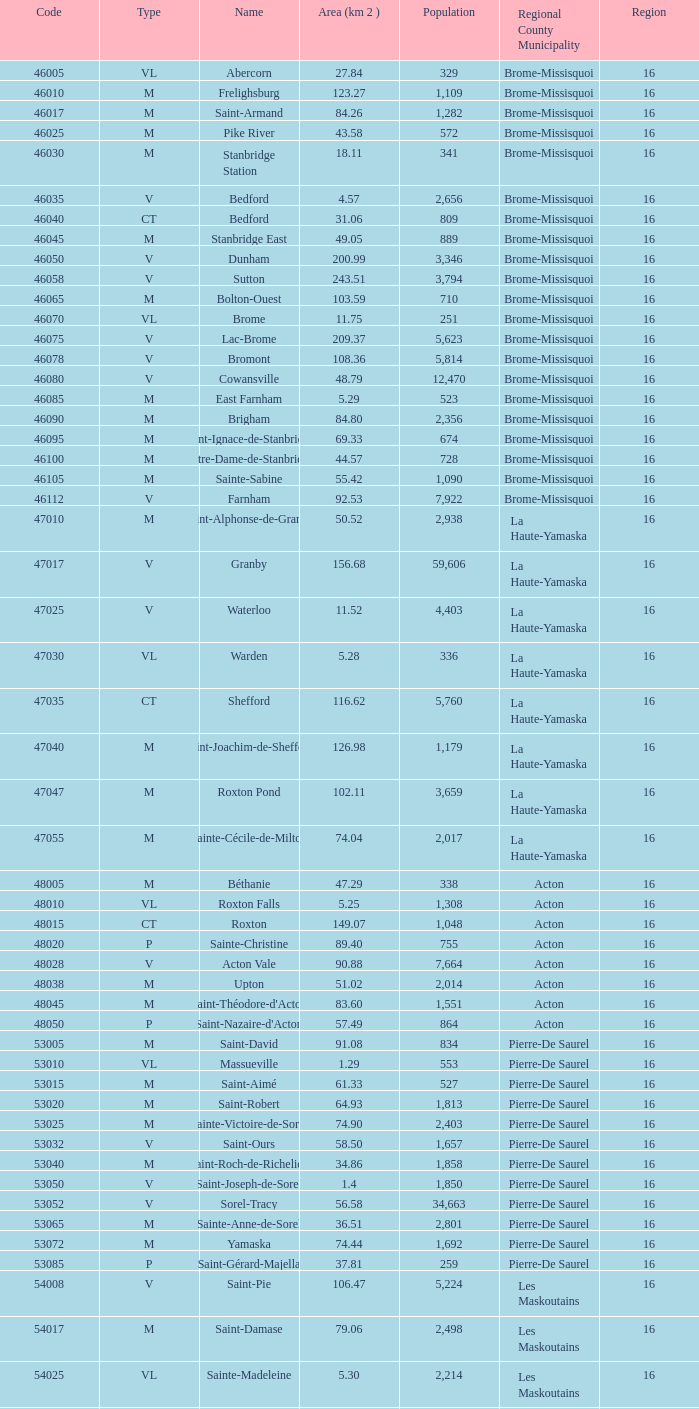What is the code for a le haut-saint-laurent municipality consisting of 16 or more regions? None. I'm looking to parse the entire table for insights. Could you assist me with that? {'header': ['Code', 'Type', 'Name', 'Area (km 2 )', 'Population', 'Regional County Municipality', 'Region'], 'rows': [['46005', 'VL', 'Abercorn', '27.84', '329', 'Brome-Missisquoi', '16'], ['46010', 'M', 'Frelighsburg', '123.27', '1,109', 'Brome-Missisquoi', '16'], ['46017', 'M', 'Saint-Armand', '84.26', '1,282', 'Brome-Missisquoi', '16'], ['46025', 'M', 'Pike River', '43.58', '572', 'Brome-Missisquoi', '16'], ['46030', 'M', 'Stanbridge Station', '18.11', '341', 'Brome-Missisquoi', '16'], ['46035', 'V', 'Bedford', '4.57', '2,656', 'Brome-Missisquoi', '16'], ['46040', 'CT', 'Bedford', '31.06', '809', 'Brome-Missisquoi', '16'], ['46045', 'M', 'Stanbridge East', '49.05', '889', 'Brome-Missisquoi', '16'], ['46050', 'V', 'Dunham', '200.99', '3,346', 'Brome-Missisquoi', '16'], ['46058', 'V', 'Sutton', '243.51', '3,794', 'Brome-Missisquoi', '16'], ['46065', 'M', 'Bolton-Ouest', '103.59', '710', 'Brome-Missisquoi', '16'], ['46070', 'VL', 'Brome', '11.75', '251', 'Brome-Missisquoi', '16'], ['46075', 'V', 'Lac-Brome', '209.37', '5,623', 'Brome-Missisquoi', '16'], ['46078', 'V', 'Bromont', '108.36', '5,814', 'Brome-Missisquoi', '16'], ['46080', 'V', 'Cowansville', '48.79', '12,470', 'Brome-Missisquoi', '16'], ['46085', 'M', 'East Farnham', '5.29', '523', 'Brome-Missisquoi', '16'], ['46090', 'M', 'Brigham', '84.80', '2,356', 'Brome-Missisquoi', '16'], ['46095', 'M', 'Saint-Ignace-de-Stanbridge', '69.33', '674', 'Brome-Missisquoi', '16'], ['46100', 'M', 'Notre-Dame-de-Stanbridge', '44.57', '728', 'Brome-Missisquoi', '16'], ['46105', 'M', 'Sainte-Sabine', '55.42', '1,090', 'Brome-Missisquoi', '16'], ['46112', 'V', 'Farnham', '92.53', '7,922', 'Brome-Missisquoi', '16'], ['47010', 'M', 'Saint-Alphonse-de-Granby', '50.52', '2,938', 'La Haute-Yamaska', '16'], ['47017', 'V', 'Granby', '156.68', '59,606', 'La Haute-Yamaska', '16'], ['47025', 'V', 'Waterloo', '11.52', '4,403', 'La Haute-Yamaska', '16'], ['47030', 'VL', 'Warden', '5.28', '336', 'La Haute-Yamaska', '16'], ['47035', 'CT', 'Shefford', '116.62', '5,760', 'La Haute-Yamaska', '16'], ['47040', 'M', 'Saint-Joachim-de-Shefford', '126.98', '1,179', 'La Haute-Yamaska', '16'], ['47047', 'M', 'Roxton Pond', '102.11', '3,659', 'La Haute-Yamaska', '16'], ['47055', 'M', 'Sainte-Cécile-de-Milton', '74.04', '2,017', 'La Haute-Yamaska', '16'], ['48005', 'M', 'Béthanie', '47.29', '338', 'Acton', '16'], ['48010', 'VL', 'Roxton Falls', '5.25', '1,308', 'Acton', '16'], ['48015', 'CT', 'Roxton', '149.07', '1,048', 'Acton', '16'], ['48020', 'P', 'Sainte-Christine', '89.40', '755', 'Acton', '16'], ['48028', 'V', 'Acton Vale', '90.88', '7,664', 'Acton', '16'], ['48038', 'M', 'Upton', '51.02', '2,014', 'Acton', '16'], ['48045', 'M', "Saint-Théodore-d'Acton", '83.60', '1,551', 'Acton', '16'], ['48050', 'P', "Saint-Nazaire-d'Acton", '57.49', '864', 'Acton', '16'], ['53005', 'M', 'Saint-David', '91.08', '834', 'Pierre-De Saurel', '16'], ['53010', 'VL', 'Massueville', '1.29', '553', 'Pierre-De Saurel', '16'], ['53015', 'M', 'Saint-Aimé', '61.33', '527', 'Pierre-De Saurel', '16'], ['53020', 'M', 'Saint-Robert', '64.93', '1,813', 'Pierre-De Saurel', '16'], ['53025', 'M', 'Sainte-Victoire-de-Sorel', '74.90', '2,403', 'Pierre-De Saurel', '16'], ['53032', 'V', 'Saint-Ours', '58.50', '1,657', 'Pierre-De Saurel', '16'], ['53040', 'M', 'Saint-Roch-de-Richelieu', '34.86', '1,858', 'Pierre-De Saurel', '16'], ['53050', 'V', 'Saint-Joseph-de-Sorel', '1.4', '1,850', 'Pierre-De Saurel', '16'], ['53052', 'V', 'Sorel-Tracy', '56.58', '34,663', 'Pierre-De Saurel', '16'], ['53065', 'M', 'Sainte-Anne-de-Sorel', '36.51', '2,801', 'Pierre-De Saurel', '16'], ['53072', 'M', 'Yamaska', '74.44', '1,692', 'Pierre-De Saurel', '16'], ['53085', 'P', 'Saint-Gérard-Majella', '37.81', '259', 'Pierre-De Saurel', '16'], ['54008', 'V', 'Saint-Pie', '106.47', '5,224', 'Les Maskoutains', '16'], ['54017', 'M', 'Saint-Damase', '79.06', '2,498', 'Les Maskoutains', '16'], ['54025', 'VL', 'Sainte-Madeleine', '5.30', '2,214', 'Les Maskoutains', '16'], ['54030', 'P', 'Sainte-Marie-Madeleine', '49.53', '2,713', 'Les Maskoutains', '16'], ['54035', 'M', 'La Présentation', '104.71', '2,078', 'Les Maskoutains', '16'], ['54048', 'V', 'Saint-Hyacinthe', '189.11', '51,984', 'Les Maskoutains', '16'], ['54060', 'M', 'Saint-Dominique', '70.16', '2,308', 'Les Maskoutains', '16'], ['54065', 'M', 'Saint-Valérien-de-Milton', '106.44', '1,785', 'Les Maskoutains', '16'], ['54072', 'M', 'Saint-Liboire', '72.90', '2,846', 'Les Maskoutains', '16'], ['54090', 'M', 'Saint-Simon', '68.66', '1,136', 'Les Maskoutains', '16'], ['54095', 'M', 'Sainte-Hélène-de-Bagot', '73.53', '1,541', 'Les Maskoutains', '16'], ['54100', 'M', 'Saint-Hugues', '89.30', '1,420', 'Les Maskoutains', '16'], ['54105', 'M', 'Saint-Barnabé-Sud', '57.08', '881', 'Les Maskoutains', '16'], ['54110', 'M', 'Saint-Jude', '77.36', '1,111', 'Les Maskoutains', '16'], ['54115', 'M', 'Saint-Bernard-de-Michaudville', '64.80', '581', 'Les Maskoutains', '16'], ['54120', 'M', 'Saint-Louis', '45.92', '752', 'Les Maskoutains', '16'], ['54125', 'M', 'Saint-Marcel-de-Richelieu', '50.21', '613', 'Les Maskoutains', '16'], ['55008', 'M', 'Ange-Gardien', '89.07', '1,994', 'Rouville', '16'], ['55015', 'M', "Saint-Paul-d'Abbotsford", '79.59', '2,910', 'Rouville', '16'], ['55023', 'V', 'Saint-Césaire', '84.14', '5,039', 'Rouville', '16'], ['55030', 'M', 'Sainte-Angèle-de-Monnoir', '45.49', '1,474', 'Rouville', '16'], ['55037', 'M', 'Rougemont', '44.48', '2,631', 'Rouville', '16'], ['55048', 'V', 'Marieville', '64.25', '7,377', 'Rouville', '16'], ['55057', 'V', 'Richelieu', '29.75', '5,658', 'Rouville', '16'], ['55065', 'M', 'Saint-Mathias-sur-Richelieu', '48.22', '4,453', 'Rouville', '16'], ['56005', 'M', 'Venise-en-Québec', '13.57', '1,414', 'Le Haut-Richelieu', '16'], ['56010', 'M', 'Saint-Georges-de-Clarenceville', '63.76', '1,170', 'Le Haut-Richelieu', '16'], ['56015', 'M', 'Noyan', '43.79', '1,192', 'Le Haut-Richelieu', '16'], ['56023', 'M', 'Lacolle', '49.17', '2,502', 'Le Haut-Richelieu', '16'], ['56030', 'M', 'Saint-Valentin', '40.09', '527', 'Le Haut-Richelieu', '16'], ['56035', 'M', "Saint-Paul-de-l'Île-aux-Noix", '29.47', '2,049', 'Le Haut-Richelieu', '16'], ['56042', 'M', 'Henryville', '64.87', '1,520', 'Le Haut-Richelieu', '16'], ['56050', 'M', 'Saint-Sébastien', '62.65', '759', 'Le Haut-Richelieu', '16'], ['56055', 'M', 'Saint-Alexandre', '76.55', '2,517', 'Le Haut-Richelieu', '16'], ['56060', 'P', 'Sainte-Anne-de-Sabrevois', '45.24', '1,964', 'Le Haut-Richelieu', '16'], ['56065', 'M', 'Saint-Blaise-sur-Richelieu', '68.42', '2,040', 'Le Haut-Richelieu', '16'], ['56083', 'V', 'Saint-Jean-sur-Richelieu', '225.61', '86,802', 'Le Haut-Richelieu', '16'], ['56097', 'M', 'Mont-Saint-Grégoire', '79.92', '3,077', 'Le Haut-Richelieu', '16'], ['56105', 'M', "Sainte-Brigide-d'Iberville", '68.89', '1,260', 'Le Haut-Richelieu', '16'], ['57005', 'V', 'Chambly', '25.01', '22,332', 'La Vallée-du-Richelieu', '16'], ['57010', 'V', 'Carignan', '62.39', '6,911', 'La Vallée-du-Richelieu', '16'], ['57020', 'V', 'Saint-Basile-le-Grand', '34.82', '15,100', 'La Vallée-du-Richelieu', '16'], ['57025', 'M', 'McMasterville', '3.00', '4,773', 'La Vallée-du-Richelieu', '16'], ['57030', 'V', 'Otterburn Park', '5.20', '8,696', 'La Vallée-du-Richelieu', '16'], ['57033', 'M', 'Saint-Jean-Baptiste', '75.98', '2,875', 'La Vallée-du-Richelieu', '16'], ['57035', 'V', 'Mont-Saint-Hilaire', '38.96', '15,820', 'La Vallée-du-Richelieu', '16'], ['57040', 'V', 'Beloeil', '24.00', '19,428', 'La Vallée-du-Richelieu', '16'], ['57045', 'M', 'Saint-Mathieu-de-Beloeil', '39.26', '2,381', 'La Vallée-du-Richelieu', '16'], ['57050', 'M', 'Saint-Marc-sur-Richelieu', '59.51', '1,992', 'La Vallée-du-Richelieu', '16'], ['57057', 'M', 'Saint-Charles-sur-Richelieu', '63.59', '1,808', 'La Vallée-du-Richelieu', '16'], ['57068', 'M', 'Saint-Denis-sur-Richelieu', '82.20', '2,272', 'La Vallée-du-Richelieu', '16'], ['57075', 'M', 'Saint-Antoine-sur-Richelieu', '65.26', '1,571', 'La Vallée-du-Richelieu', '16'], ['58007', 'V', 'Brossard', '44.77', '71,372', 'Not part of a RCM', '16'], ['58012', 'V', 'Saint-Lambert', '6.43', '21,772', 'Not part of a RCM', '16'], ['58033', 'V', 'Boucherville', '69.33', '38,526', 'Not part of a RCM', '16'], ['58037', 'V', 'Saint-Bruno-de-Montarville', '41.89', '24,571', 'Not part of a RCM', '16'], ['58227', 'V', 'Longueuil', '111.50', '231,969', 'Not part of a RCM', '16'], ['59010', 'V', 'Sainte-Julie', '47.78', '29,000', "Marguerite-D'Youville", '16'], ['59015', 'M', 'Saint-Amable', '38.04', '8,135', "Marguerite-D'Youville", '16'], ['59020', 'V', 'Varennes', '93.96', '20,608', "Marguerite-D'Youville", '16'], ['59025', 'M', 'Verchères', '72.77', '5,103', "Marguerite-D'Youville", '16'], ['59030', 'P', 'Calixa-Lavallée', '32.42', '517', "Marguerite-D'Youville", '16'], ['59035', 'V', 'Contrecœur', '61.56', '5,603', "Marguerite-D'Youville", '16'], ['67005', 'M', 'Saint-Mathieu', '32.27', '2,032', 'Roussillon', '16'], ['67010', 'M', 'Saint-Philippe', '61.66', '4,763', 'Roussillon', '16'], ['67015', 'V', 'La Prairie', '43.53', '21,609', 'Roussillon', '16'], ['67020', 'V', 'Candiac', '16.40', '14,866', 'Roussillon', '16'], ['67025', 'V', 'Delson', '7.76', '7,382', 'Roussillon', '16'], ['67030', 'V', 'Sainte-Catherine', '9.06', '16,770', 'Roussillon', '16'], ['67035', 'V', 'Saint-Constant', '56.58', '24,679', 'Roussillon', '16'], ['67040', 'P', 'Saint-Isidore', '52.00', '2,476', 'Roussillon', '16'], ['67045', 'V', 'Mercier', '45.89', '10,231', 'Roussillon', '16'], ['67050', 'V', 'Châteauguay', '35.37', '43,178', 'Roussillon', '16'], ['67055', 'V', 'Léry', '10.98', '2,368', 'Roussillon', '16'], ['68005', 'P', 'Saint-Bernard-de-Lacolle', '112.63', '1,601', 'Les Jardins-de-Napierville', '16'], ['68010', 'VL', 'Hemmingford', '0.85', '737', 'Les Jardins-de-Napierville', '16'], ['68015', 'CT', 'Hemmingford', '155.78', '1,735', 'Les Jardins-de-Napierville', '16'], ['68020', 'M', 'Sainte-Clotilde', '78.96', '1,593', 'Les Jardins-de-Napierville', '16'], ['68025', 'M', 'Saint-Patrice-de-Sherrington', '91.47', '1,946', 'Les Jardins-de-Napierville', '16'], ['68030', 'M', 'Napierville', '4.53', '3,310', 'Les Jardins-de-Napierville', '16'], ['68035', 'M', 'Saint-Cyprien-de-Napierville', '97.62', '1,414', 'Les Jardins-de-Napierville', '16'], ['68040', 'M', 'Saint-Jacques-le-Mineur', '65.19', '1,670', 'Les Jardins-de-Napierville', '16'], ['68045', 'M', 'Saint-Édouard', '52.91', '1,226', 'Les Jardins-de-Napierville', '16'], ['68050', 'M', 'Saint-Michel', '57.36', '2,681', 'Les Jardins-de-Napierville', '16'], ['68055', 'V', 'Saint-Rémi', '79.66', '6,089', 'Les Jardins-de-Napierville', '16'], ['69005', 'CT', 'Havelock', '87.98', '853', 'Le Haut-Saint-Laurent', '16'], ['69010', 'M', 'Franklin', '112.19', '1,601', 'Le Haut-Saint-Laurent', '16'], ['69017', 'M', 'Saint-Chrysostome', '99.54', '2,689', 'Le Haut-Saint-Laurent', '16'], ['69025', 'M', 'Howick', '0.89', '589', 'Le Haut-Saint-Laurent', '16'], ['69030', 'P', 'Très-Saint-Sacrement', '97.30', '1,250', 'Le Haut-Saint-Laurent', '16'], ['69037', 'M', 'Ormstown', '142.39', '3,742', 'Le Haut-Saint-Laurent', '16'], ['69045', 'M', 'Hinchinbrooke', '148.95', '2,425', 'Le Haut-Saint-Laurent', '16'], ['69050', 'M', 'Elgin', '69.38', '463', 'Le Haut-Saint-Laurent', '16'], ['69055', 'V', 'Huntingdon', '2.58', '2,695', 'Le Haut-Saint-Laurent', '16'], ['69060', 'CT', 'Godmanchester', '138.77', '1,512', 'Le Haut-Saint-Laurent', '16'], ['69065', 'M', 'Sainte-Barbe', '39.78', '1,407', 'Le Haut-Saint-Laurent', '16'], ['69070', 'M', 'Saint-Anicet', '136.25', '2,736', 'Le Haut-Saint-Laurent', '16'], ['69075', 'CT', 'Dundee', '94.20', '406', 'Le Haut-Saint-Laurent', '16'], ['70005', 'M', 'Saint-Urbain-Premier', '52.24', '1,181', 'Beauharnois-Salaberry', '16'], ['70012', 'M', 'Sainte-Martine', '59.79', '4,037', 'Beauharnois-Salaberry', '16'], ['70022', 'V', 'Beauharnois', '73.05', '12,041', 'Beauharnois-Salaberry', '16'], ['70030', 'M', 'Saint-Étienne-de-Beauharnois', '41.62', '738', 'Beauharnois-Salaberry', '16'], ['70035', 'P', 'Saint-Louis-de-Gonzague', '78.52', '1,402', 'Beauharnois-Salaberry', '16'], ['70040', 'M', 'Saint-Stanislas-de-Kostka', '62.16', '1,653', 'Beauharnois-Salaberry', '16'], ['70052', 'V', 'Salaberry-de-Valleyfield', '100.96', '40,056', 'Beauharnois-Salaberry', '16'], ['71005', 'M', 'Rivière-Beaudette', '19.62', '1,701', 'Vaudreuil-Soulanges', '16'], ['71015', 'M', 'Saint-Télesphore', '59.62', '777', 'Vaudreuil-Soulanges', '16'], ['71020', 'M', 'Saint-Polycarpe', '70.80', '1,737', 'Vaudreuil-Soulanges', '16'], ['71025', 'M', 'Saint-Zotique', '24.24', '4,947', 'Vaudreuil-Soulanges', '16'], ['71033', 'M', 'Les Coteaux', '12.11', '3,684', 'Vaudreuil-Soulanges', '16'], ['71040', 'V', 'Coteau-du-Lac', '46.57', '6,458', 'Vaudreuil-Soulanges', '16'], ['71045', 'M', 'Saint-Clet', '38.61', '1,663', 'Vaudreuil-Soulanges', '16'], ['71050', 'M', 'Les Cèdres', '78.31', '5,842', 'Vaudreuil-Soulanges', '16'], ['71055', 'VL', 'Pointe-des-Cascades', '2.66', '1,014', 'Vaudreuil-Soulanges', '16'], ['71060', 'V', "L'Île-Perrot", '4.86', '10,131', 'Vaudreuil-Soulanges', '16'], ['71065', 'V', "Notre-Dame-de-l'Île-Perrot", '28.14', '9,783', 'Vaudreuil-Soulanges', '16'], ['71070', 'V', 'Pincourt', '8.36', '10,960', 'Vaudreuil-Soulanges', '16'], ['71075', 'M', 'Terrasse-Vaudreuil', '1.08', '2,086', 'Vaudreuil-Soulanges', '16'], ['71083', 'V', 'Vaudreuil-Dorion', '73.18', '24,589', 'Vaudreuil-Soulanges', '16'], ['71090', 'VL', 'Vaudreuil-sur-le-Lac', '1.73', '1,058', 'Vaudreuil-Soulanges', '16'], ['71095', 'V', "L'Île-Cadieux", '0.62', '141', 'Vaudreuil-Soulanges', '16'], ['71100', 'V', 'Hudson', '21.62', '5,193', 'Vaudreuil-Soulanges', '16'], ['71105', 'V', 'Saint-Lazare', '67.59', '15,954', 'Vaudreuil-Soulanges', '16'], ['71110', 'M', 'Sainte-Marthe', '80.23', '1,142', 'Vaudreuil-Soulanges', '16'], ['71115', 'M', 'Sainte-Justine-de-Newton', '84.14', '968', 'Vaudreuil-Soulanges', '16'], ['71125', 'M', 'Très-Saint-Rédempteur', '25.40', '645', 'Vaudreuil-Soulanges', '16'], ['71133', 'M', 'Rigaud', '97.15', '6,724', 'Vaudreuil-Soulanges', '16'], ['71140', 'VL', 'Pointe-Fortune', '9.09', '512', 'Vaudreuil-Soulanges', '16']]} 